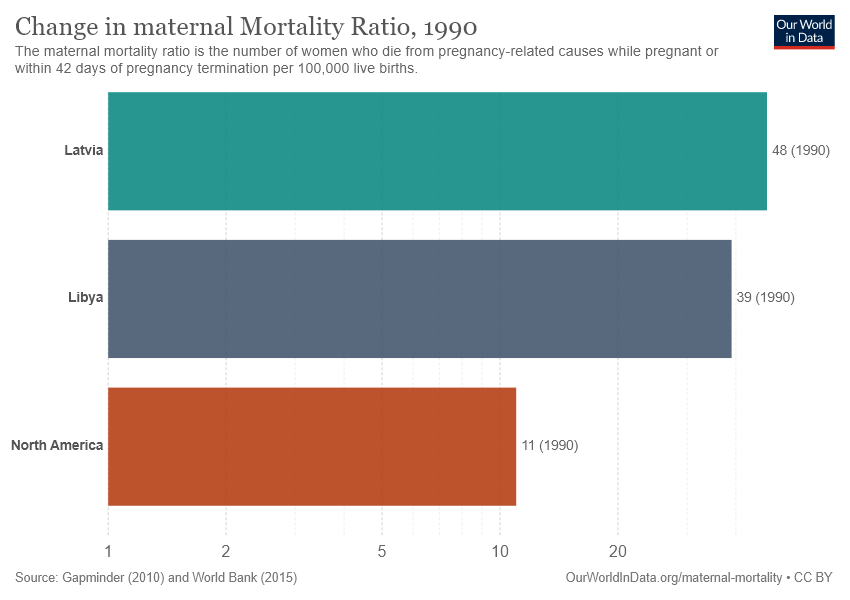Specify some key components in this picture. The chart contains 3 bars. The sum of the smallest two bars is greater than the value of the largest bar. 